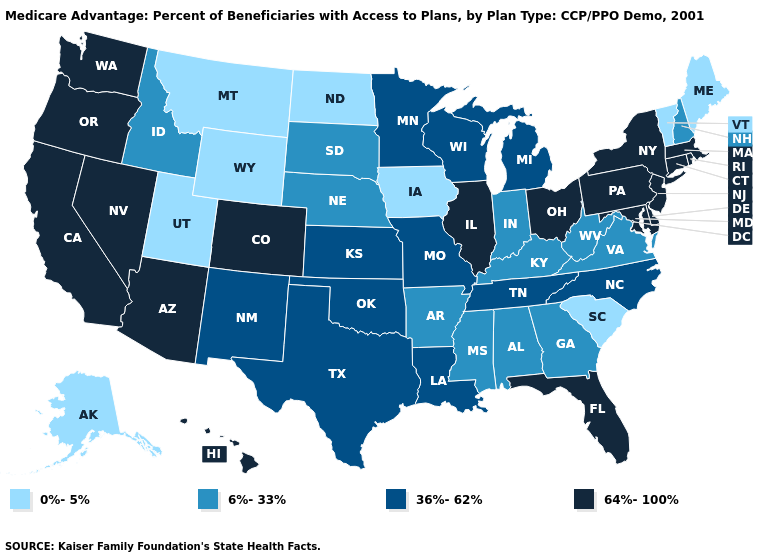Among the states that border California , which have the highest value?
Give a very brief answer. Arizona, Nevada, Oregon. Which states have the lowest value in the Northeast?
Write a very short answer. Maine, Vermont. Which states have the lowest value in the West?
Quick response, please. Alaska, Montana, Utah, Wyoming. What is the value of South Carolina?
Concise answer only. 0%-5%. What is the highest value in states that border Maryland?
Answer briefly. 64%-100%. What is the highest value in the MidWest ?
Keep it brief. 64%-100%. What is the value of Minnesota?
Write a very short answer. 36%-62%. Name the states that have a value in the range 6%-33%?
Answer briefly. Alabama, Arkansas, Georgia, Idaho, Indiana, Kentucky, Mississippi, Nebraska, New Hampshire, South Dakota, Virginia, West Virginia. Does the first symbol in the legend represent the smallest category?
Keep it brief. Yes. Name the states that have a value in the range 0%-5%?
Answer briefly. Alaska, Iowa, Maine, Montana, North Dakota, South Carolina, Utah, Vermont, Wyoming. Which states have the lowest value in the USA?
Give a very brief answer. Alaska, Iowa, Maine, Montana, North Dakota, South Carolina, Utah, Vermont, Wyoming. What is the highest value in states that border New Mexico?
Give a very brief answer. 64%-100%. Does the first symbol in the legend represent the smallest category?
Short answer required. Yes. What is the lowest value in the USA?
Be succinct. 0%-5%. Does the map have missing data?
Concise answer only. No. 